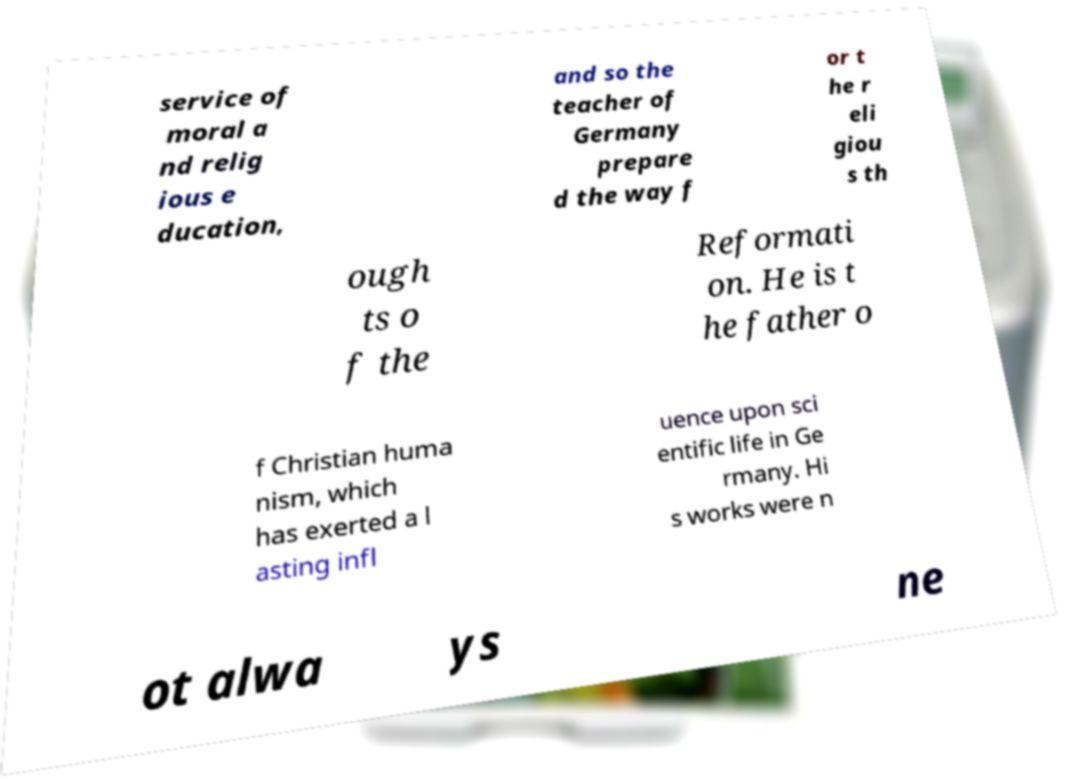Can you accurately transcribe the text from the provided image for me? service of moral a nd relig ious e ducation, and so the teacher of Germany prepare d the way f or t he r eli giou s th ough ts o f the Reformati on. He is t he father o f Christian huma nism, which has exerted a l asting infl uence upon sci entific life in Ge rmany. Hi s works were n ot alwa ys ne 